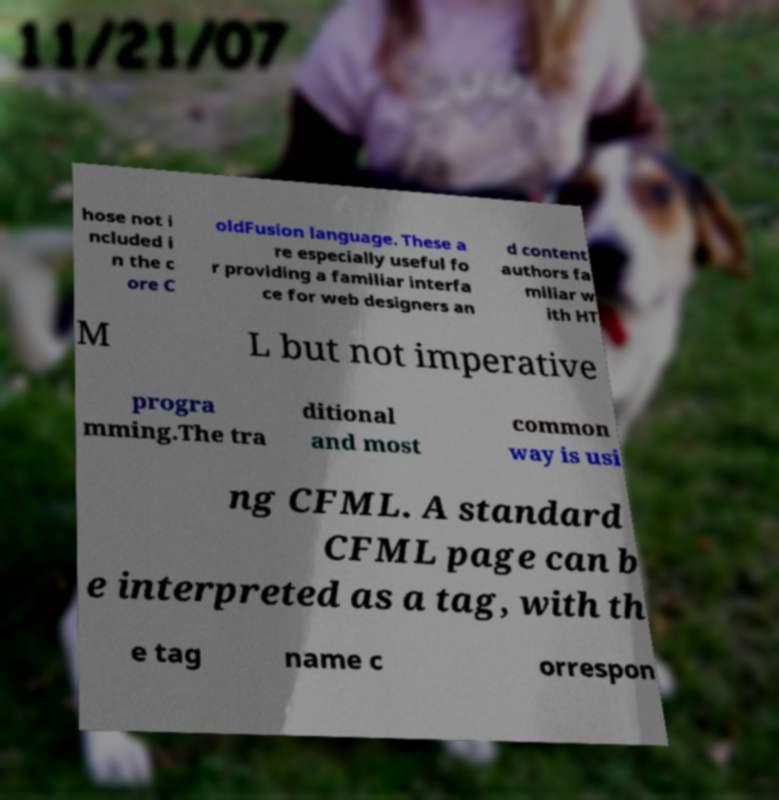Can you accurately transcribe the text from the provided image for me? hose not i ncluded i n the c ore C oldFusion language. These a re especially useful fo r providing a familiar interfa ce for web designers an d content authors fa miliar w ith HT M L but not imperative progra mming.The tra ditional and most common way is usi ng CFML. A standard CFML page can b e interpreted as a tag, with th e tag name c orrespon 